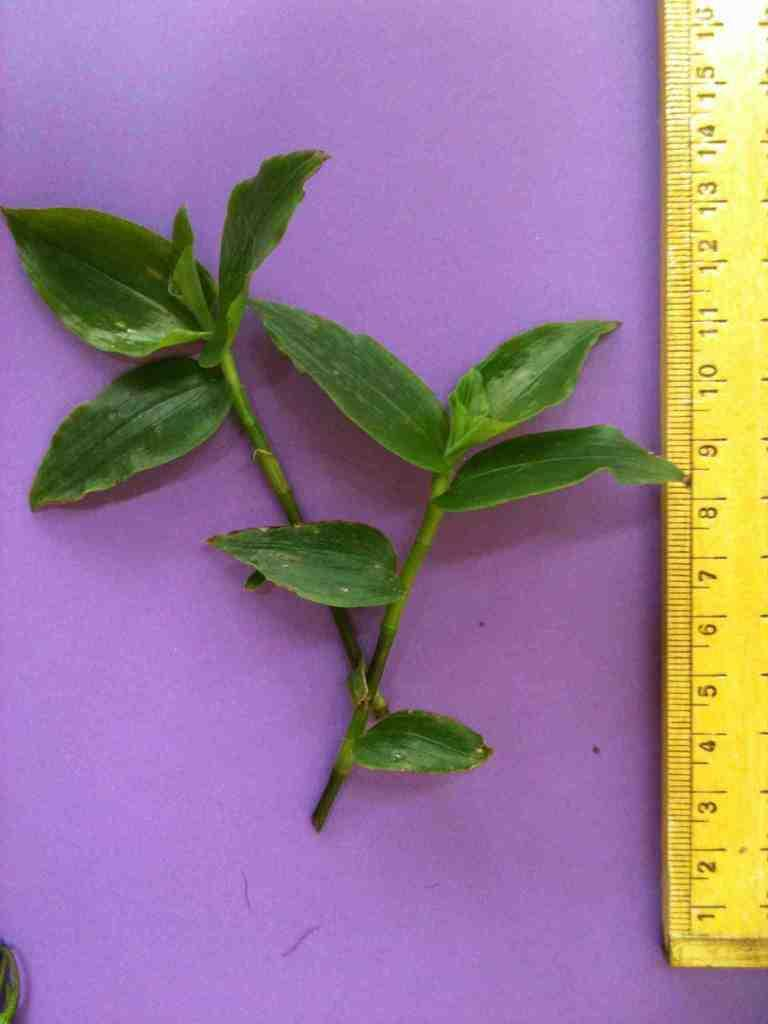<image>
Relay a brief, clear account of the picture shown. A yellow ruler numbered from 1 to 16 centimeters measures a green plant. 